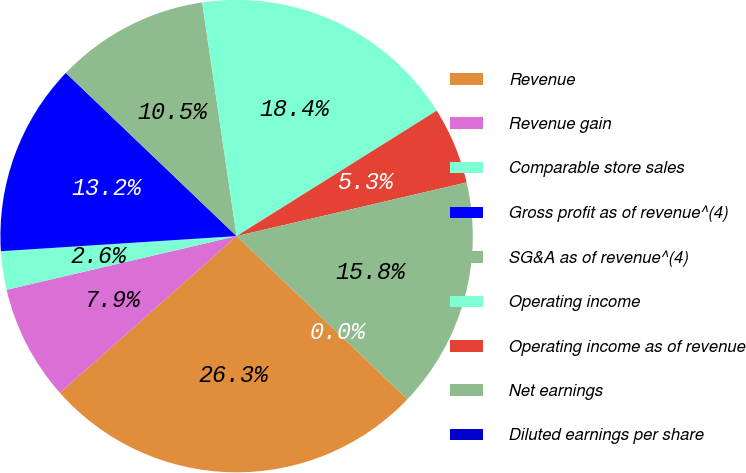<chart> <loc_0><loc_0><loc_500><loc_500><pie_chart><fcel>Revenue<fcel>Revenue gain<fcel>Comparable store sales<fcel>Gross profit as of revenue^(4)<fcel>SG&A as of revenue^(4)<fcel>Operating income<fcel>Operating income as of revenue<fcel>Net earnings<fcel>Diluted earnings per share<nl><fcel>26.31%<fcel>7.9%<fcel>2.63%<fcel>13.16%<fcel>10.53%<fcel>18.42%<fcel>5.26%<fcel>15.79%<fcel>0.0%<nl></chart> 